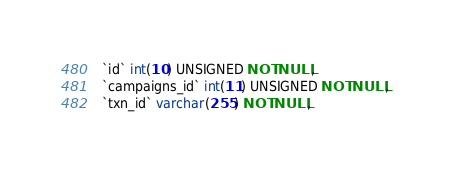Convert code to text. <code><loc_0><loc_0><loc_500><loc_500><_SQL_>  `id` int(10) UNSIGNED NOT NULL,
  `campaigns_id` int(11) UNSIGNED NOT NULL,
  `txn_id` varchar(255) NOT NULL,</code> 